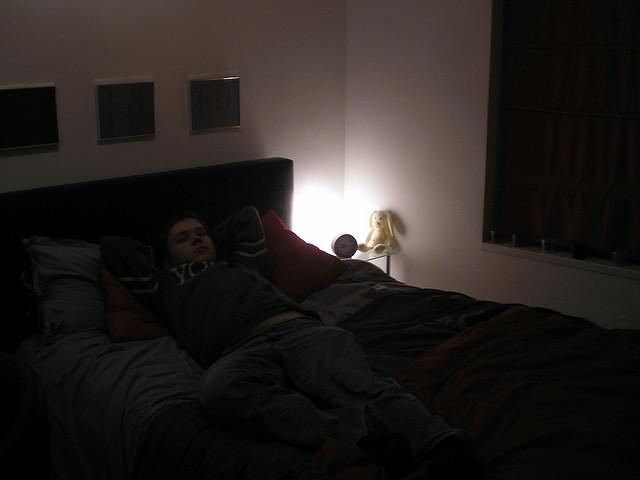What is given off light?
Give a very brief answer. Lamp. Is the boy asleep?
Give a very brief answer. No. Where is the clock located?
Short answer required. Nightstand. Can you see a computer?
Give a very brief answer. No. Is this bed a mess?
Short answer required. No. What type of animal is in the picture?
Keep it brief. None. Is it night outside?
Write a very short answer. Yes. What color hair does the person have?
Short answer required. Brown. IS this a boy or girl's room?
Short answer required. Boy. Are the children sleeping?
Quick response, please. Yes. How many pillows can be seen on the bed?
Be succinct. 3. Are they eating dog food?
Keep it brief. No. What is the boy sleeping on?
Short answer required. Bed. What is shining in the corner?
Concise answer only. Lamp. How many kids are laying on the bed?
Be succinct. 1. Are there curtains on the windows?
Quick response, please. Yes. Is this a girl's room or a boy's room?
Be succinct. Boy's. Are the people sleepy?
Keep it brief. Yes. Has this been used yet?
Answer briefly. Yes. How many people are sleeping on the bed?
Concise answer only. 1. Where is the human's face?
Give a very brief answer. Left. What is this room?
Write a very short answer. Bedroom. How many framed pictures can be seen?
Give a very brief answer. 3. Is this person tired?
Quick response, please. Yes. How many creatures are sleeping?
Write a very short answer. 1. What is by the light?
Answer briefly. Clock. What color are the sheets in this photo?
Keep it brief. Gray. 